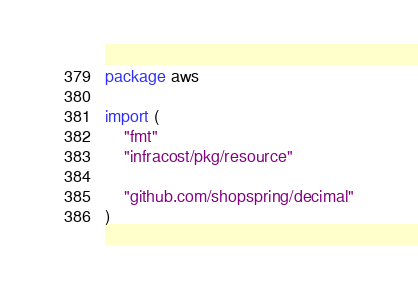Convert code to text. <code><loc_0><loc_0><loc_500><loc_500><_Go_>package aws

import (
	"fmt"
	"infracost/pkg/resource"

	"github.com/shopspring/decimal"
)
</code> 